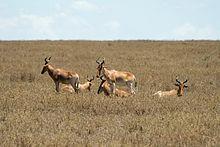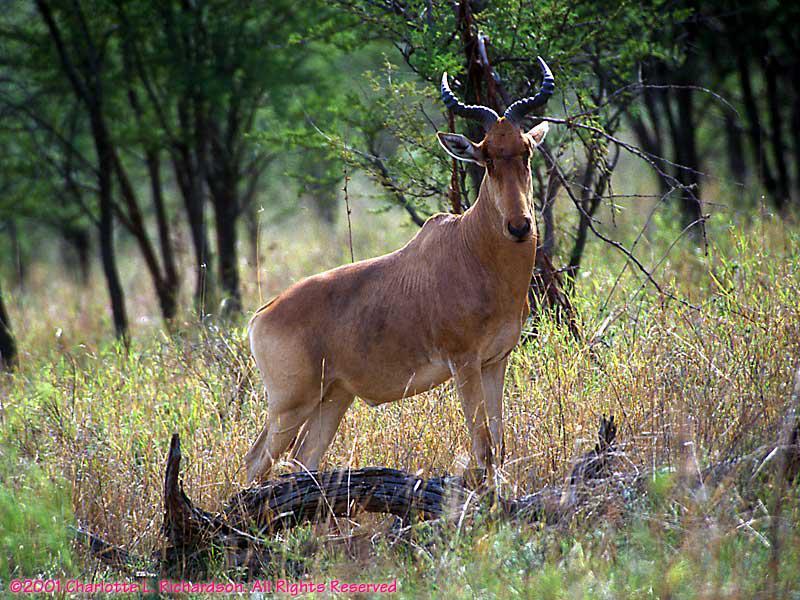The first image is the image on the left, the second image is the image on the right. Analyze the images presented: Is the assertion "There are more than 8 animals total." valid? Answer yes or no. No. 